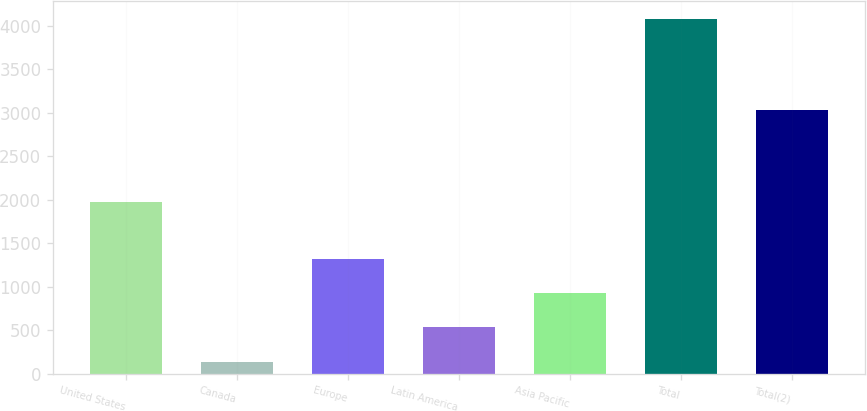Convert chart. <chart><loc_0><loc_0><loc_500><loc_500><bar_chart><fcel>United States<fcel>Canada<fcel>Europe<fcel>Latin America<fcel>Asia Pacific<fcel>Total<fcel>Total(2)<nl><fcel>1972.9<fcel>140.3<fcel>1323.74<fcel>534.78<fcel>929.26<fcel>4085.1<fcel>3038.4<nl></chart> 